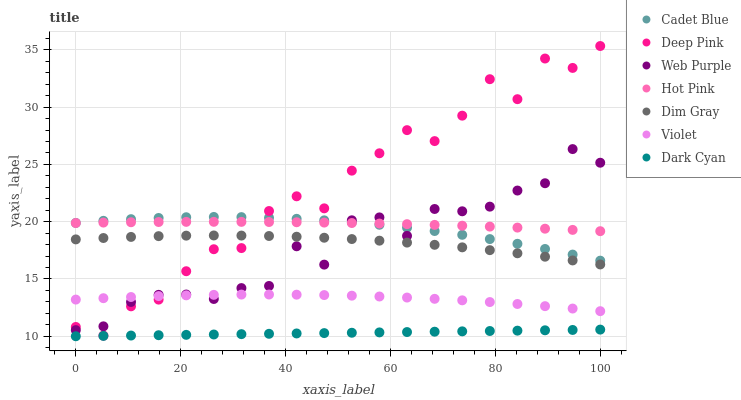Does Dark Cyan have the minimum area under the curve?
Answer yes or no. Yes. Does Deep Pink have the maximum area under the curve?
Answer yes or no. Yes. Does Hot Pink have the minimum area under the curve?
Answer yes or no. No. Does Hot Pink have the maximum area under the curve?
Answer yes or no. No. Is Dark Cyan the smoothest?
Answer yes or no. Yes. Is Deep Pink the roughest?
Answer yes or no. Yes. Is Hot Pink the smoothest?
Answer yes or no. No. Is Hot Pink the roughest?
Answer yes or no. No. Does Dark Cyan have the lowest value?
Answer yes or no. Yes. Does Deep Pink have the lowest value?
Answer yes or no. No. Does Deep Pink have the highest value?
Answer yes or no. Yes. Does Hot Pink have the highest value?
Answer yes or no. No. Is Violet less than Hot Pink?
Answer yes or no. Yes. Is Dim Gray greater than Violet?
Answer yes or no. Yes. Does Deep Pink intersect Violet?
Answer yes or no. Yes. Is Deep Pink less than Violet?
Answer yes or no. No. Is Deep Pink greater than Violet?
Answer yes or no. No. Does Violet intersect Hot Pink?
Answer yes or no. No. 